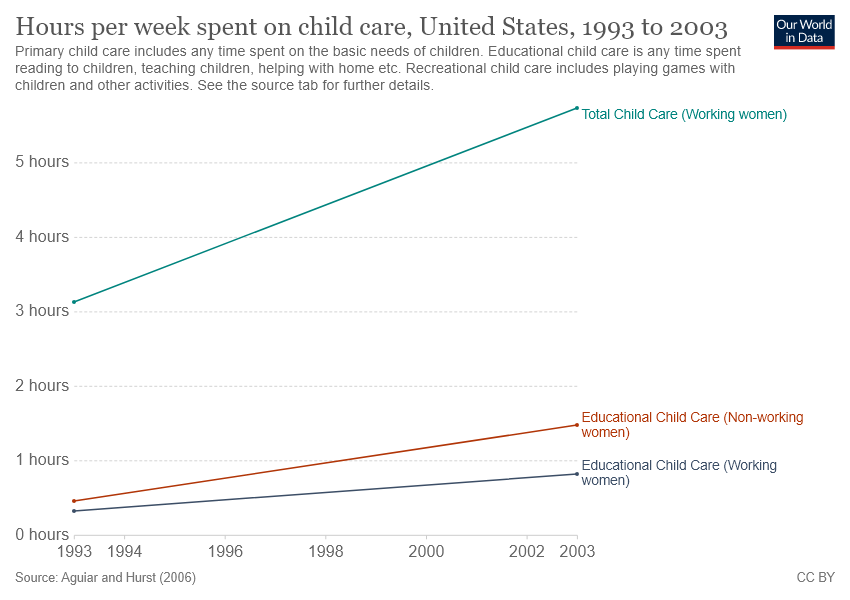List a handful of essential elements in this visual. In 2003, the maximum amount of time spent on educational child care for non-working women was recorded. In 1993, the least amount of time was spent on educational child care for non-working women. 